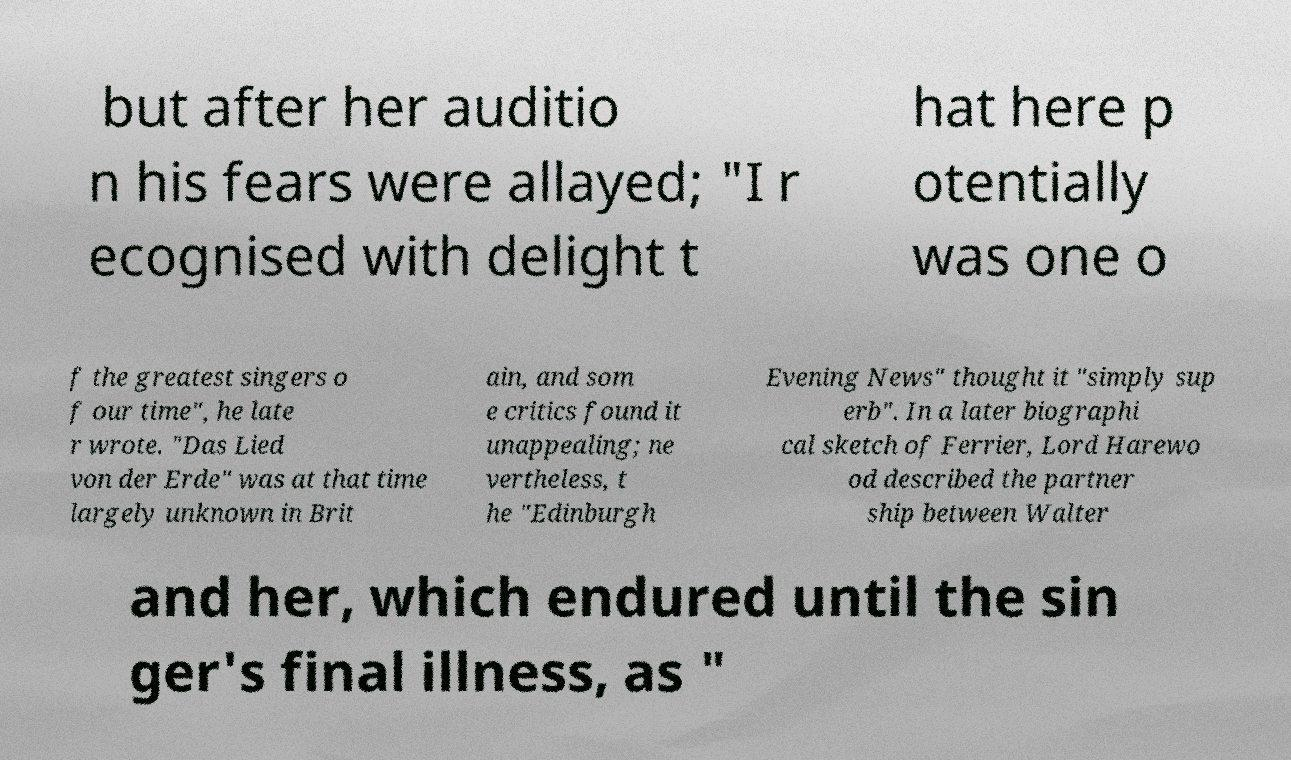Please identify and transcribe the text found in this image. but after her auditio n his fears were allayed; "I r ecognised with delight t hat here p otentially was one o f the greatest singers o f our time", he late r wrote. "Das Lied von der Erde" was at that time largely unknown in Brit ain, and som e critics found it unappealing; ne vertheless, t he "Edinburgh Evening News" thought it "simply sup erb". In a later biographi cal sketch of Ferrier, Lord Harewo od described the partner ship between Walter and her, which endured until the sin ger's final illness, as " 